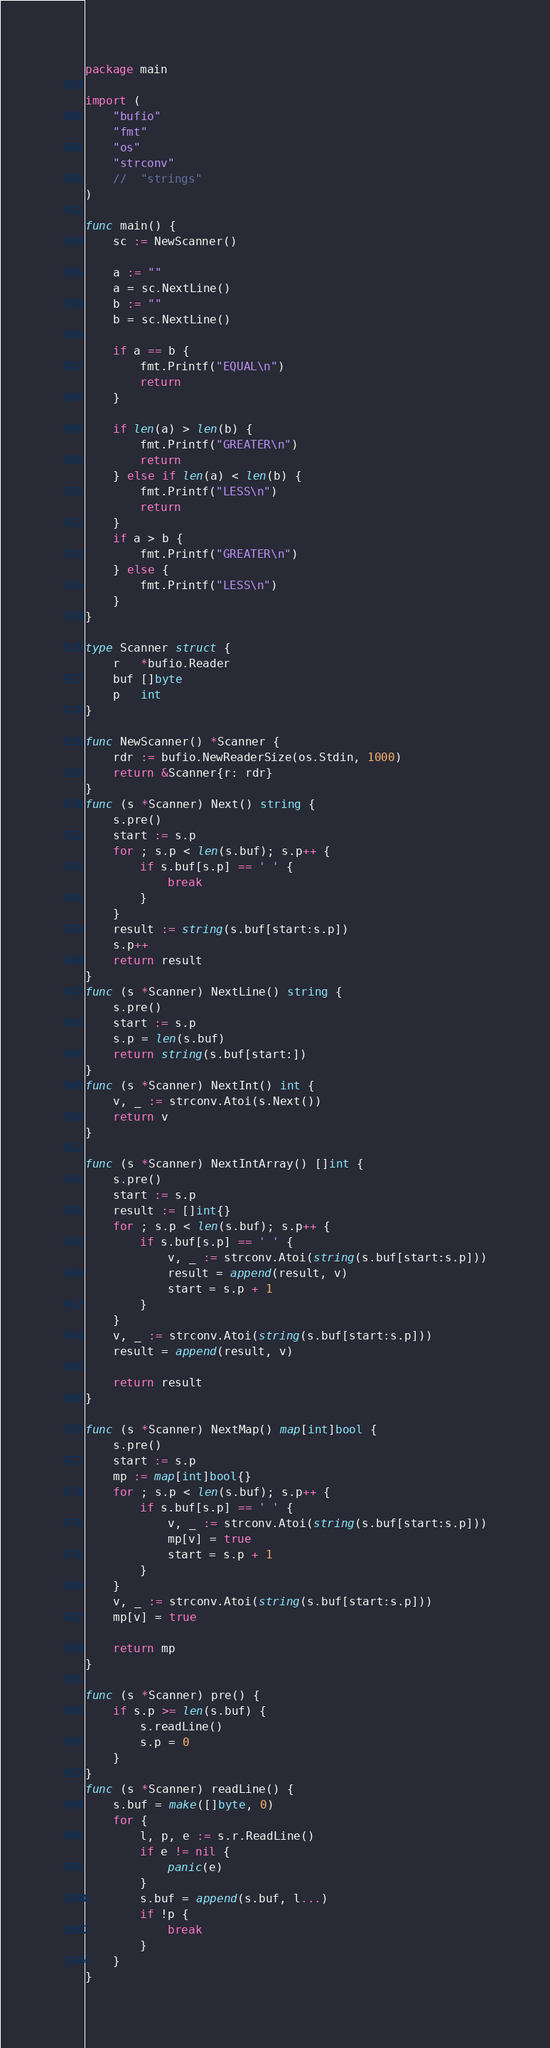<code> <loc_0><loc_0><loc_500><loc_500><_Go_>package main

import (
	"bufio"
	"fmt"
	"os"
	"strconv"
	//	"strings"
)

func main() {
	sc := NewScanner()

	a := ""
	a = sc.NextLine()
	b := ""
	b = sc.NextLine()

	if a == b {
		fmt.Printf("EQUAL\n")
		return
	}

	if len(a) > len(b) {
		fmt.Printf("GREATER\n")
		return
	} else if len(a) < len(b) {
		fmt.Printf("LESS\n")
		return
	}
	if a > b {
		fmt.Printf("GREATER\n")
	} else {
		fmt.Printf("LESS\n")
	}
}

type Scanner struct {
	r   *bufio.Reader
	buf []byte
	p   int
}

func NewScanner() *Scanner {
	rdr := bufio.NewReaderSize(os.Stdin, 1000)
	return &Scanner{r: rdr}
}
func (s *Scanner) Next() string {
	s.pre()
	start := s.p
	for ; s.p < len(s.buf); s.p++ {
		if s.buf[s.p] == ' ' {
			break
		}
	}
	result := string(s.buf[start:s.p])
	s.p++
	return result
}
func (s *Scanner) NextLine() string {
	s.pre()
	start := s.p
	s.p = len(s.buf)
	return string(s.buf[start:])
}
func (s *Scanner) NextInt() int {
	v, _ := strconv.Atoi(s.Next())
	return v
}

func (s *Scanner) NextIntArray() []int {
	s.pre()
	start := s.p
	result := []int{}
	for ; s.p < len(s.buf); s.p++ {
		if s.buf[s.p] == ' ' {
			v, _ := strconv.Atoi(string(s.buf[start:s.p]))
			result = append(result, v)
			start = s.p + 1
		}
	}
	v, _ := strconv.Atoi(string(s.buf[start:s.p]))
	result = append(result, v)

	return result
}

func (s *Scanner) NextMap() map[int]bool {
	s.pre()
	start := s.p
	mp := map[int]bool{}
	for ; s.p < len(s.buf); s.p++ {
		if s.buf[s.p] == ' ' {
			v, _ := strconv.Atoi(string(s.buf[start:s.p]))
			mp[v] = true
			start = s.p + 1
		}
	}
	v, _ := strconv.Atoi(string(s.buf[start:s.p]))
	mp[v] = true

	return mp
}

func (s *Scanner) pre() {
	if s.p >= len(s.buf) {
		s.readLine()
		s.p = 0
	}
}
func (s *Scanner) readLine() {
	s.buf = make([]byte, 0)
	for {
		l, p, e := s.r.ReadLine()
		if e != nil {
			panic(e)
		}
		s.buf = append(s.buf, l...)
		if !p {
			break
		}
	}
}
</code> 